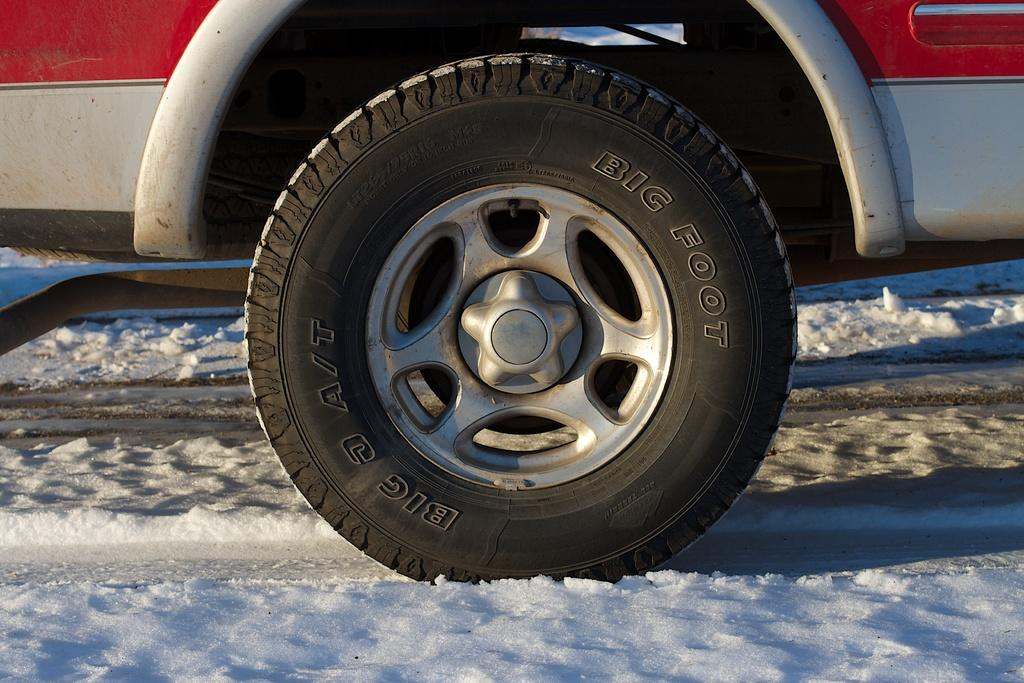What is the main subject of the picture? The main subject of the picture is a tire of a vehicle. What colors can be seen on the vehicle? The vehicle is in red and grey color. What is the condition of the land in the picture? There is snow on the land. What time of day is it in the image, and what type of soda is being served? The time of day is not mentioned in the image, and there is no soda present in the image. 